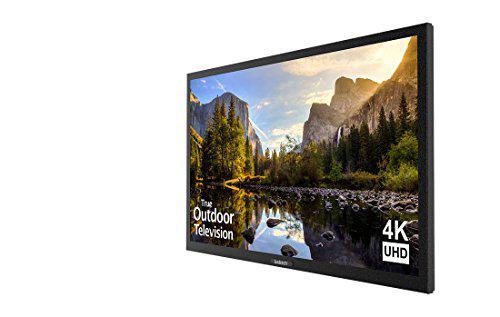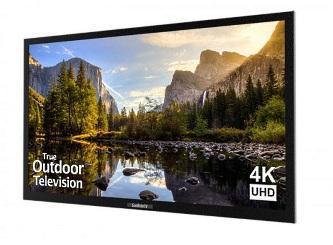The first image is the image on the left, the second image is the image on the right. For the images shown, is this caption "A TV shows picture quality by displaying a picture of pink flowers beneath sky with clouds." true? Answer yes or no. No. The first image is the image on the left, the second image is the image on the right. Considering the images on both sides, is "One of the TVs has flowers on the display." valid? Answer yes or no. No. 